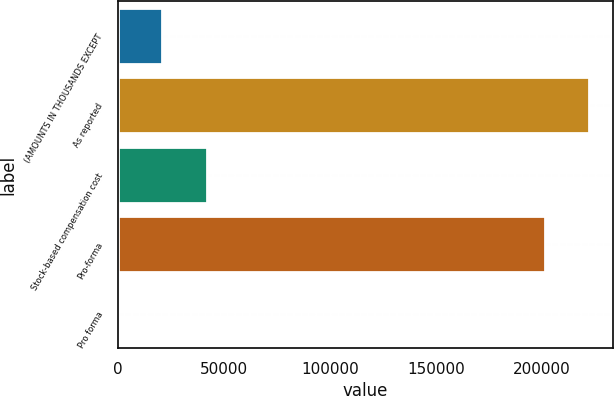Convert chart. <chart><loc_0><loc_0><loc_500><loc_500><bar_chart><fcel>(AMOUNTS IN THOUSANDS EXCEPT<fcel>As reported<fcel>Stock-based compensation cost<fcel>Pro-forma<fcel>Pro forma<nl><fcel>20975.3<fcel>222538<fcel>41948.7<fcel>201565<fcel>1.84<nl></chart> 